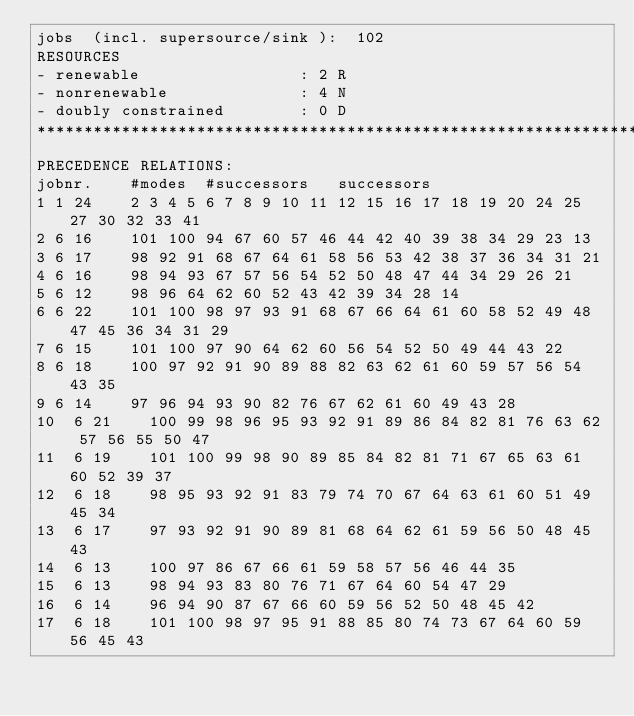<code> <loc_0><loc_0><loc_500><loc_500><_ObjectiveC_>jobs  (incl. supersource/sink ):	102
RESOURCES
- renewable                 : 2 R
- nonrenewable              : 4 N
- doubly constrained        : 0 D
************************************************************************
PRECEDENCE RELATIONS:
jobnr.    #modes  #successors   successors
1	1	24		2 3 4 5 6 7 8 9 10 11 12 15 16 17 18 19 20 24 25 27 30 32 33 41 
2	6	16		101 100 94 67 60 57 46 44 42 40 39 38 34 29 23 13 
3	6	17		98 92 91 68 67 64 61 58 56 53 42 38 37 36 34 31 21 
4	6	16		98 94 93 67 57 56 54 52 50 48 47 44 34 29 26 21 
5	6	12		98 96 64 62 60 52 43 42 39 34 28 14 
6	6	22		101 100 98 97 93 91 68 67 66 64 61 60 58 52 49 48 47 45 36 34 31 29 
7	6	15		101 100 97 90 64 62 60 56 54 52 50 49 44 43 22 
8	6	18		100 97 92 91 90 89 88 82 63 62 61 60 59 57 56 54 43 35 
9	6	14		97 96 94 93 90 82 76 67 62 61 60 49 43 28 
10	6	21		100 99 98 96 95 93 92 91 89 86 84 82 81 76 63 62 57 56 55 50 47 
11	6	19		101 100 99 98 90 89 85 84 82 81 71 67 65 63 61 60 52 39 37 
12	6	18		98 95 93 92 91 83 79 74 70 67 64 63 61 60 51 49 45 34 
13	6	17		97 93 92 91 90 89 81 68 64 62 61 59 56 50 48 45 43 
14	6	13		100 97 86 67 66 61 59 58 57 56 46 44 35 
15	6	13		98 94 93 83 80 76 71 67 64 60 54 47 29 
16	6	14		96 94 90 87 67 66 60 59 56 52 50 48 45 42 
17	6	18		101 100 98 97 95 91 88 85 80 74 73 67 64 60 59 56 45 43 </code> 